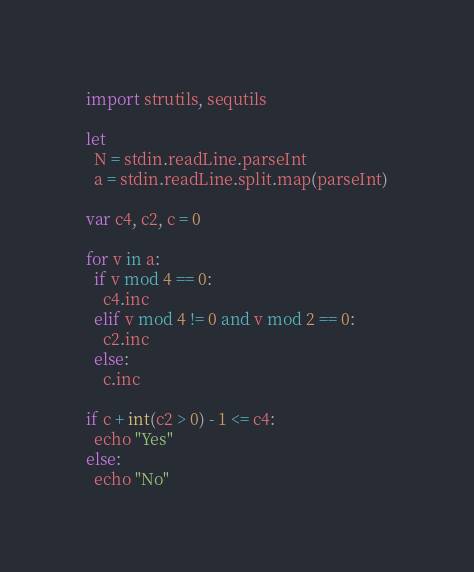<code> <loc_0><loc_0><loc_500><loc_500><_Nim_>import strutils, sequtils

let
  N = stdin.readLine.parseInt
  a = stdin.readLine.split.map(parseInt)
 
var c4, c2, c = 0

for v in a:
  if v mod 4 == 0:
    c4.inc
  elif v mod 4 != 0 and v mod 2 == 0:
    c2.inc
  else:
    c.inc

if c + int(c2 > 0) - 1 <= c4:
  echo "Yes"
else:
  echo "No"
</code> 